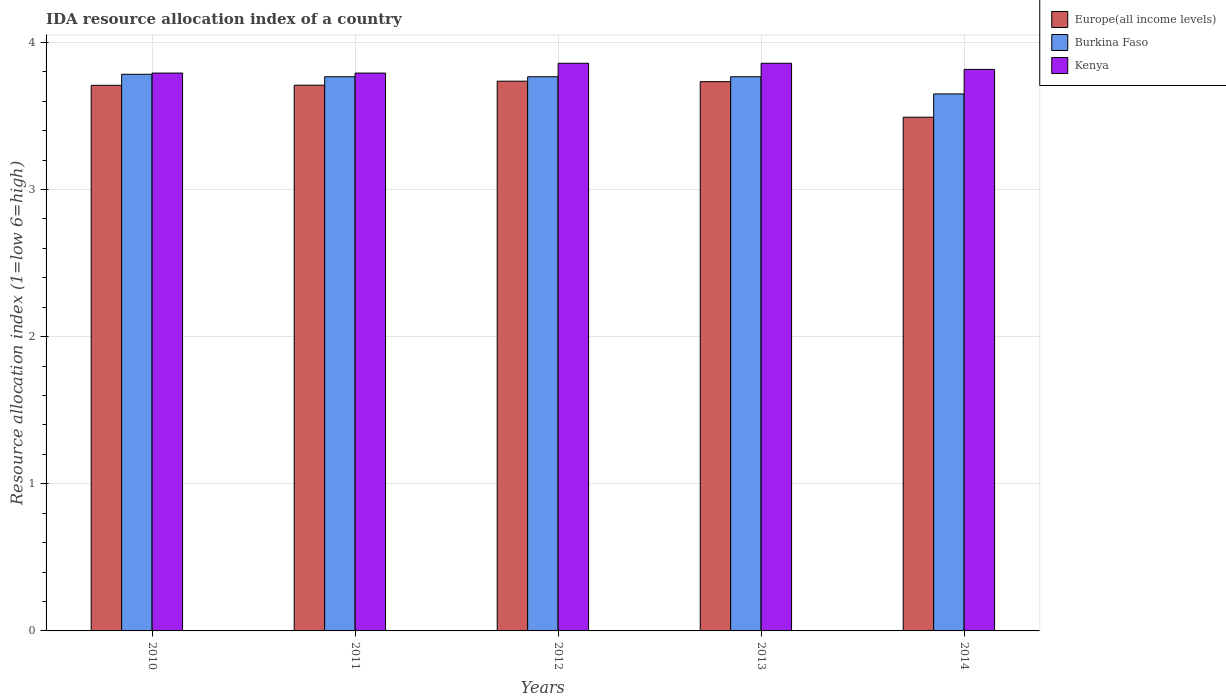How many different coloured bars are there?
Keep it short and to the point. 3. Are the number of bars per tick equal to the number of legend labels?
Offer a very short reply. Yes. Are the number of bars on each tick of the X-axis equal?
Give a very brief answer. Yes. How many bars are there on the 4th tick from the left?
Your response must be concise. 3. How many bars are there on the 2nd tick from the right?
Ensure brevity in your answer.  3. What is the label of the 2nd group of bars from the left?
Provide a succinct answer. 2011. In how many cases, is the number of bars for a given year not equal to the number of legend labels?
Make the answer very short. 0. What is the IDA resource allocation index in Kenya in 2014?
Make the answer very short. 3.82. Across all years, what is the maximum IDA resource allocation index in Burkina Faso?
Provide a short and direct response. 3.78. Across all years, what is the minimum IDA resource allocation index in Burkina Faso?
Offer a terse response. 3.65. In which year was the IDA resource allocation index in Burkina Faso minimum?
Your answer should be compact. 2014. What is the total IDA resource allocation index in Kenya in the graph?
Offer a terse response. 19.12. What is the difference between the IDA resource allocation index in Burkina Faso in 2011 and that in 2013?
Provide a succinct answer. 0. What is the difference between the IDA resource allocation index in Europe(all income levels) in 2014 and the IDA resource allocation index in Kenya in 2013?
Ensure brevity in your answer.  -0.37. What is the average IDA resource allocation index in Kenya per year?
Your response must be concise. 3.82. In the year 2011, what is the difference between the IDA resource allocation index in Kenya and IDA resource allocation index in Burkina Faso?
Offer a terse response. 0.02. What is the ratio of the IDA resource allocation index in Kenya in 2011 to that in 2014?
Offer a very short reply. 0.99. Is the IDA resource allocation index in Europe(all income levels) in 2010 less than that in 2014?
Give a very brief answer. No. Is the difference between the IDA resource allocation index in Kenya in 2011 and 2012 greater than the difference between the IDA resource allocation index in Burkina Faso in 2011 and 2012?
Ensure brevity in your answer.  No. What is the difference between the highest and the second highest IDA resource allocation index in Europe(all income levels)?
Your response must be concise. 0. What is the difference between the highest and the lowest IDA resource allocation index in Europe(all income levels)?
Give a very brief answer. 0.24. What does the 3rd bar from the left in 2013 represents?
Make the answer very short. Kenya. What does the 3rd bar from the right in 2010 represents?
Ensure brevity in your answer.  Europe(all income levels). Is it the case that in every year, the sum of the IDA resource allocation index in Burkina Faso and IDA resource allocation index in Kenya is greater than the IDA resource allocation index in Europe(all income levels)?
Ensure brevity in your answer.  Yes. Are the values on the major ticks of Y-axis written in scientific E-notation?
Make the answer very short. No. Does the graph contain any zero values?
Provide a succinct answer. No. Does the graph contain grids?
Give a very brief answer. Yes. Where does the legend appear in the graph?
Ensure brevity in your answer.  Top right. How are the legend labels stacked?
Make the answer very short. Vertical. What is the title of the graph?
Your answer should be compact. IDA resource allocation index of a country. What is the label or title of the X-axis?
Your answer should be very brief. Years. What is the label or title of the Y-axis?
Your answer should be compact. Resource allocation index (1=low 6=high). What is the Resource allocation index (1=low 6=high) in Europe(all income levels) in 2010?
Provide a short and direct response. 3.71. What is the Resource allocation index (1=low 6=high) in Burkina Faso in 2010?
Your answer should be compact. 3.78. What is the Resource allocation index (1=low 6=high) of Kenya in 2010?
Offer a very short reply. 3.79. What is the Resource allocation index (1=low 6=high) of Europe(all income levels) in 2011?
Ensure brevity in your answer.  3.71. What is the Resource allocation index (1=low 6=high) in Burkina Faso in 2011?
Give a very brief answer. 3.77. What is the Resource allocation index (1=low 6=high) of Kenya in 2011?
Provide a succinct answer. 3.79. What is the Resource allocation index (1=low 6=high) in Europe(all income levels) in 2012?
Provide a succinct answer. 3.74. What is the Resource allocation index (1=low 6=high) in Burkina Faso in 2012?
Your response must be concise. 3.77. What is the Resource allocation index (1=low 6=high) of Kenya in 2012?
Your answer should be compact. 3.86. What is the Resource allocation index (1=low 6=high) of Europe(all income levels) in 2013?
Your answer should be compact. 3.73. What is the Resource allocation index (1=low 6=high) in Burkina Faso in 2013?
Offer a terse response. 3.77. What is the Resource allocation index (1=low 6=high) in Kenya in 2013?
Offer a very short reply. 3.86. What is the Resource allocation index (1=low 6=high) in Europe(all income levels) in 2014?
Give a very brief answer. 3.49. What is the Resource allocation index (1=low 6=high) in Burkina Faso in 2014?
Give a very brief answer. 3.65. What is the Resource allocation index (1=low 6=high) of Kenya in 2014?
Offer a terse response. 3.82. Across all years, what is the maximum Resource allocation index (1=low 6=high) in Europe(all income levels)?
Keep it short and to the point. 3.74. Across all years, what is the maximum Resource allocation index (1=low 6=high) in Burkina Faso?
Keep it short and to the point. 3.78. Across all years, what is the maximum Resource allocation index (1=low 6=high) of Kenya?
Your answer should be very brief. 3.86. Across all years, what is the minimum Resource allocation index (1=low 6=high) of Europe(all income levels)?
Keep it short and to the point. 3.49. Across all years, what is the minimum Resource allocation index (1=low 6=high) in Burkina Faso?
Provide a short and direct response. 3.65. Across all years, what is the minimum Resource allocation index (1=low 6=high) of Kenya?
Give a very brief answer. 3.79. What is the total Resource allocation index (1=low 6=high) of Europe(all income levels) in the graph?
Provide a short and direct response. 18.38. What is the total Resource allocation index (1=low 6=high) in Burkina Faso in the graph?
Give a very brief answer. 18.73. What is the total Resource allocation index (1=low 6=high) in Kenya in the graph?
Offer a terse response. 19.12. What is the difference between the Resource allocation index (1=low 6=high) of Europe(all income levels) in 2010 and that in 2011?
Keep it short and to the point. -0. What is the difference between the Resource allocation index (1=low 6=high) in Burkina Faso in 2010 and that in 2011?
Make the answer very short. 0.02. What is the difference between the Resource allocation index (1=low 6=high) of Europe(all income levels) in 2010 and that in 2012?
Your response must be concise. -0.03. What is the difference between the Resource allocation index (1=low 6=high) in Burkina Faso in 2010 and that in 2012?
Offer a terse response. 0.02. What is the difference between the Resource allocation index (1=low 6=high) of Kenya in 2010 and that in 2012?
Ensure brevity in your answer.  -0.07. What is the difference between the Resource allocation index (1=low 6=high) in Europe(all income levels) in 2010 and that in 2013?
Offer a terse response. -0.03. What is the difference between the Resource allocation index (1=low 6=high) in Burkina Faso in 2010 and that in 2013?
Your response must be concise. 0.02. What is the difference between the Resource allocation index (1=low 6=high) of Kenya in 2010 and that in 2013?
Provide a succinct answer. -0.07. What is the difference between the Resource allocation index (1=low 6=high) in Europe(all income levels) in 2010 and that in 2014?
Provide a succinct answer. 0.22. What is the difference between the Resource allocation index (1=low 6=high) of Burkina Faso in 2010 and that in 2014?
Give a very brief answer. 0.13. What is the difference between the Resource allocation index (1=low 6=high) in Kenya in 2010 and that in 2014?
Ensure brevity in your answer.  -0.03. What is the difference between the Resource allocation index (1=low 6=high) in Europe(all income levels) in 2011 and that in 2012?
Offer a very short reply. -0.03. What is the difference between the Resource allocation index (1=low 6=high) in Kenya in 2011 and that in 2012?
Give a very brief answer. -0.07. What is the difference between the Resource allocation index (1=low 6=high) in Europe(all income levels) in 2011 and that in 2013?
Ensure brevity in your answer.  -0.02. What is the difference between the Resource allocation index (1=low 6=high) of Kenya in 2011 and that in 2013?
Keep it short and to the point. -0.07. What is the difference between the Resource allocation index (1=low 6=high) of Europe(all income levels) in 2011 and that in 2014?
Your answer should be compact. 0.22. What is the difference between the Resource allocation index (1=low 6=high) in Burkina Faso in 2011 and that in 2014?
Keep it short and to the point. 0.12. What is the difference between the Resource allocation index (1=low 6=high) in Kenya in 2011 and that in 2014?
Your response must be concise. -0.03. What is the difference between the Resource allocation index (1=low 6=high) of Europe(all income levels) in 2012 and that in 2013?
Give a very brief answer. 0. What is the difference between the Resource allocation index (1=low 6=high) in Europe(all income levels) in 2012 and that in 2014?
Offer a terse response. 0.24. What is the difference between the Resource allocation index (1=low 6=high) of Burkina Faso in 2012 and that in 2014?
Offer a very short reply. 0.12. What is the difference between the Resource allocation index (1=low 6=high) in Kenya in 2012 and that in 2014?
Provide a short and direct response. 0.04. What is the difference between the Resource allocation index (1=low 6=high) of Europe(all income levels) in 2013 and that in 2014?
Your answer should be compact. 0.24. What is the difference between the Resource allocation index (1=low 6=high) of Burkina Faso in 2013 and that in 2014?
Provide a short and direct response. 0.12. What is the difference between the Resource allocation index (1=low 6=high) in Kenya in 2013 and that in 2014?
Provide a succinct answer. 0.04. What is the difference between the Resource allocation index (1=low 6=high) of Europe(all income levels) in 2010 and the Resource allocation index (1=low 6=high) of Burkina Faso in 2011?
Provide a short and direct response. -0.06. What is the difference between the Resource allocation index (1=low 6=high) of Europe(all income levels) in 2010 and the Resource allocation index (1=low 6=high) of Kenya in 2011?
Give a very brief answer. -0.08. What is the difference between the Resource allocation index (1=low 6=high) of Burkina Faso in 2010 and the Resource allocation index (1=low 6=high) of Kenya in 2011?
Your answer should be compact. -0.01. What is the difference between the Resource allocation index (1=low 6=high) in Europe(all income levels) in 2010 and the Resource allocation index (1=low 6=high) in Burkina Faso in 2012?
Provide a short and direct response. -0.06. What is the difference between the Resource allocation index (1=low 6=high) of Burkina Faso in 2010 and the Resource allocation index (1=low 6=high) of Kenya in 2012?
Provide a short and direct response. -0.07. What is the difference between the Resource allocation index (1=low 6=high) in Europe(all income levels) in 2010 and the Resource allocation index (1=low 6=high) in Burkina Faso in 2013?
Offer a very short reply. -0.06. What is the difference between the Resource allocation index (1=low 6=high) in Europe(all income levels) in 2010 and the Resource allocation index (1=low 6=high) in Kenya in 2013?
Offer a very short reply. -0.15. What is the difference between the Resource allocation index (1=low 6=high) in Burkina Faso in 2010 and the Resource allocation index (1=low 6=high) in Kenya in 2013?
Keep it short and to the point. -0.07. What is the difference between the Resource allocation index (1=low 6=high) in Europe(all income levels) in 2010 and the Resource allocation index (1=low 6=high) in Burkina Faso in 2014?
Offer a very short reply. 0.06. What is the difference between the Resource allocation index (1=low 6=high) in Europe(all income levels) in 2010 and the Resource allocation index (1=low 6=high) in Kenya in 2014?
Make the answer very short. -0.11. What is the difference between the Resource allocation index (1=low 6=high) in Burkina Faso in 2010 and the Resource allocation index (1=low 6=high) in Kenya in 2014?
Keep it short and to the point. -0.03. What is the difference between the Resource allocation index (1=low 6=high) in Europe(all income levels) in 2011 and the Resource allocation index (1=low 6=high) in Burkina Faso in 2012?
Ensure brevity in your answer.  -0.06. What is the difference between the Resource allocation index (1=low 6=high) of Europe(all income levels) in 2011 and the Resource allocation index (1=low 6=high) of Kenya in 2012?
Ensure brevity in your answer.  -0.15. What is the difference between the Resource allocation index (1=low 6=high) in Burkina Faso in 2011 and the Resource allocation index (1=low 6=high) in Kenya in 2012?
Give a very brief answer. -0.09. What is the difference between the Resource allocation index (1=low 6=high) of Europe(all income levels) in 2011 and the Resource allocation index (1=low 6=high) of Burkina Faso in 2013?
Provide a succinct answer. -0.06. What is the difference between the Resource allocation index (1=low 6=high) in Europe(all income levels) in 2011 and the Resource allocation index (1=low 6=high) in Kenya in 2013?
Offer a terse response. -0.15. What is the difference between the Resource allocation index (1=low 6=high) in Burkina Faso in 2011 and the Resource allocation index (1=low 6=high) in Kenya in 2013?
Give a very brief answer. -0.09. What is the difference between the Resource allocation index (1=low 6=high) in Europe(all income levels) in 2011 and the Resource allocation index (1=low 6=high) in Burkina Faso in 2014?
Make the answer very short. 0.06. What is the difference between the Resource allocation index (1=low 6=high) in Europe(all income levels) in 2011 and the Resource allocation index (1=low 6=high) in Kenya in 2014?
Ensure brevity in your answer.  -0.11. What is the difference between the Resource allocation index (1=low 6=high) of Europe(all income levels) in 2012 and the Resource allocation index (1=low 6=high) of Burkina Faso in 2013?
Ensure brevity in your answer.  -0.03. What is the difference between the Resource allocation index (1=low 6=high) in Europe(all income levels) in 2012 and the Resource allocation index (1=low 6=high) in Kenya in 2013?
Your answer should be very brief. -0.12. What is the difference between the Resource allocation index (1=low 6=high) of Burkina Faso in 2012 and the Resource allocation index (1=low 6=high) of Kenya in 2013?
Offer a terse response. -0.09. What is the difference between the Resource allocation index (1=low 6=high) of Europe(all income levels) in 2012 and the Resource allocation index (1=low 6=high) of Burkina Faso in 2014?
Keep it short and to the point. 0.09. What is the difference between the Resource allocation index (1=low 6=high) of Europe(all income levels) in 2012 and the Resource allocation index (1=low 6=high) of Kenya in 2014?
Your answer should be very brief. -0.08. What is the difference between the Resource allocation index (1=low 6=high) in Burkina Faso in 2012 and the Resource allocation index (1=low 6=high) in Kenya in 2014?
Provide a short and direct response. -0.05. What is the difference between the Resource allocation index (1=low 6=high) of Europe(all income levels) in 2013 and the Resource allocation index (1=low 6=high) of Burkina Faso in 2014?
Your answer should be compact. 0.08. What is the difference between the Resource allocation index (1=low 6=high) of Europe(all income levels) in 2013 and the Resource allocation index (1=low 6=high) of Kenya in 2014?
Ensure brevity in your answer.  -0.08. What is the average Resource allocation index (1=low 6=high) of Europe(all income levels) per year?
Offer a very short reply. 3.68. What is the average Resource allocation index (1=low 6=high) of Burkina Faso per year?
Make the answer very short. 3.75. What is the average Resource allocation index (1=low 6=high) of Kenya per year?
Your response must be concise. 3.82. In the year 2010, what is the difference between the Resource allocation index (1=low 6=high) of Europe(all income levels) and Resource allocation index (1=low 6=high) of Burkina Faso?
Your answer should be compact. -0.07. In the year 2010, what is the difference between the Resource allocation index (1=low 6=high) in Europe(all income levels) and Resource allocation index (1=low 6=high) in Kenya?
Give a very brief answer. -0.08. In the year 2010, what is the difference between the Resource allocation index (1=low 6=high) of Burkina Faso and Resource allocation index (1=low 6=high) of Kenya?
Keep it short and to the point. -0.01. In the year 2011, what is the difference between the Resource allocation index (1=low 6=high) in Europe(all income levels) and Resource allocation index (1=low 6=high) in Burkina Faso?
Your answer should be compact. -0.06. In the year 2011, what is the difference between the Resource allocation index (1=low 6=high) of Europe(all income levels) and Resource allocation index (1=low 6=high) of Kenya?
Ensure brevity in your answer.  -0.08. In the year 2011, what is the difference between the Resource allocation index (1=low 6=high) in Burkina Faso and Resource allocation index (1=low 6=high) in Kenya?
Give a very brief answer. -0.03. In the year 2012, what is the difference between the Resource allocation index (1=low 6=high) of Europe(all income levels) and Resource allocation index (1=low 6=high) of Burkina Faso?
Offer a very short reply. -0.03. In the year 2012, what is the difference between the Resource allocation index (1=low 6=high) in Europe(all income levels) and Resource allocation index (1=low 6=high) in Kenya?
Provide a short and direct response. -0.12. In the year 2012, what is the difference between the Resource allocation index (1=low 6=high) of Burkina Faso and Resource allocation index (1=low 6=high) of Kenya?
Keep it short and to the point. -0.09. In the year 2013, what is the difference between the Resource allocation index (1=low 6=high) in Europe(all income levels) and Resource allocation index (1=low 6=high) in Burkina Faso?
Keep it short and to the point. -0.03. In the year 2013, what is the difference between the Resource allocation index (1=low 6=high) of Europe(all income levels) and Resource allocation index (1=low 6=high) of Kenya?
Keep it short and to the point. -0.12. In the year 2013, what is the difference between the Resource allocation index (1=low 6=high) of Burkina Faso and Resource allocation index (1=low 6=high) of Kenya?
Provide a succinct answer. -0.09. In the year 2014, what is the difference between the Resource allocation index (1=low 6=high) of Europe(all income levels) and Resource allocation index (1=low 6=high) of Burkina Faso?
Make the answer very short. -0.16. In the year 2014, what is the difference between the Resource allocation index (1=low 6=high) in Europe(all income levels) and Resource allocation index (1=low 6=high) in Kenya?
Keep it short and to the point. -0.33. In the year 2014, what is the difference between the Resource allocation index (1=low 6=high) in Burkina Faso and Resource allocation index (1=low 6=high) in Kenya?
Provide a short and direct response. -0.17. What is the ratio of the Resource allocation index (1=low 6=high) of Europe(all income levels) in 2010 to that in 2011?
Your answer should be compact. 1. What is the ratio of the Resource allocation index (1=low 6=high) in Burkina Faso in 2010 to that in 2011?
Give a very brief answer. 1. What is the ratio of the Resource allocation index (1=low 6=high) of Europe(all income levels) in 2010 to that in 2012?
Your response must be concise. 0.99. What is the ratio of the Resource allocation index (1=low 6=high) in Burkina Faso in 2010 to that in 2012?
Your answer should be very brief. 1. What is the ratio of the Resource allocation index (1=low 6=high) in Kenya in 2010 to that in 2012?
Offer a very short reply. 0.98. What is the ratio of the Resource allocation index (1=low 6=high) of Europe(all income levels) in 2010 to that in 2013?
Keep it short and to the point. 0.99. What is the ratio of the Resource allocation index (1=low 6=high) in Burkina Faso in 2010 to that in 2013?
Keep it short and to the point. 1. What is the ratio of the Resource allocation index (1=low 6=high) of Kenya in 2010 to that in 2013?
Offer a very short reply. 0.98. What is the ratio of the Resource allocation index (1=low 6=high) of Europe(all income levels) in 2010 to that in 2014?
Your answer should be very brief. 1.06. What is the ratio of the Resource allocation index (1=low 6=high) in Burkina Faso in 2010 to that in 2014?
Your answer should be compact. 1.04. What is the ratio of the Resource allocation index (1=low 6=high) of Kenya in 2010 to that in 2014?
Your answer should be compact. 0.99. What is the ratio of the Resource allocation index (1=low 6=high) of Europe(all income levels) in 2011 to that in 2012?
Make the answer very short. 0.99. What is the ratio of the Resource allocation index (1=low 6=high) in Kenya in 2011 to that in 2012?
Provide a short and direct response. 0.98. What is the ratio of the Resource allocation index (1=low 6=high) of Kenya in 2011 to that in 2013?
Give a very brief answer. 0.98. What is the ratio of the Resource allocation index (1=low 6=high) of Europe(all income levels) in 2011 to that in 2014?
Provide a short and direct response. 1.06. What is the ratio of the Resource allocation index (1=low 6=high) of Burkina Faso in 2011 to that in 2014?
Ensure brevity in your answer.  1.03. What is the ratio of the Resource allocation index (1=low 6=high) in Kenya in 2011 to that in 2014?
Offer a terse response. 0.99. What is the ratio of the Resource allocation index (1=low 6=high) of Europe(all income levels) in 2012 to that in 2013?
Ensure brevity in your answer.  1. What is the ratio of the Resource allocation index (1=low 6=high) in Kenya in 2012 to that in 2013?
Offer a terse response. 1. What is the ratio of the Resource allocation index (1=low 6=high) of Europe(all income levels) in 2012 to that in 2014?
Keep it short and to the point. 1.07. What is the ratio of the Resource allocation index (1=low 6=high) of Burkina Faso in 2012 to that in 2014?
Provide a short and direct response. 1.03. What is the ratio of the Resource allocation index (1=low 6=high) of Kenya in 2012 to that in 2014?
Give a very brief answer. 1.01. What is the ratio of the Resource allocation index (1=low 6=high) of Europe(all income levels) in 2013 to that in 2014?
Your answer should be compact. 1.07. What is the ratio of the Resource allocation index (1=low 6=high) of Burkina Faso in 2013 to that in 2014?
Offer a terse response. 1.03. What is the ratio of the Resource allocation index (1=low 6=high) in Kenya in 2013 to that in 2014?
Your answer should be very brief. 1.01. What is the difference between the highest and the second highest Resource allocation index (1=low 6=high) of Europe(all income levels)?
Give a very brief answer. 0. What is the difference between the highest and the second highest Resource allocation index (1=low 6=high) of Burkina Faso?
Your answer should be compact. 0.02. What is the difference between the highest and the lowest Resource allocation index (1=low 6=high) in Europe(all income levels)?
Ensure brevity in your answer.  0.24. What is the difference between the highest and the lowest Resource allocation index (1=low 6=high) of Burkina Faso?
Give a very brief answer. 0.13. What is the difference between the highest and the lowest Resource allocation index (1=low 6=high) of Kenya?
Keep it short and to the point. 0.07. 